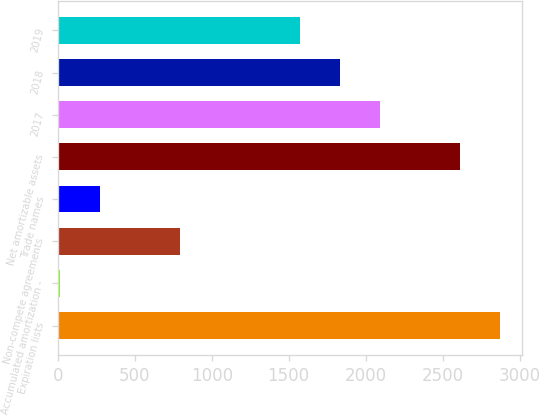Convert chart to OTSL. <chart><loc_0><loc_0><loc_500><loc_500><bar_chart><fcel>Expiration lists<fcel>Accumulated amortization -<fcel>Non-compete agreements<fcel>Trade names<fcel>Net amortizable assets<fcel>2017<fcel>2018<fcel>2019<nl><fcel>2873.19<fcel>14.4<fcel>794.07<fcel>274.29<fcel>2613.3<fcel>2093.52<fcel>1833.63<fcel>1573.74<nl></chart> 